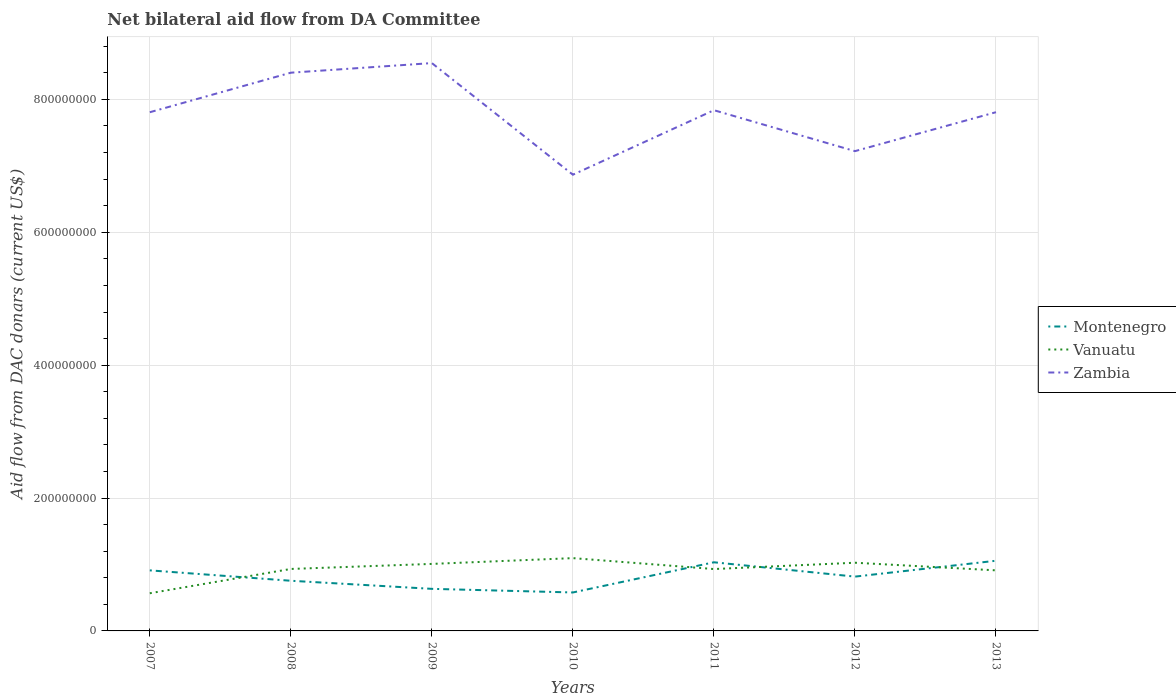Is the number of lines equal to the number of legend labels?
Make the answer very short. Yes. Across all years, what is the maximum aid flow in in Zambia?
Offer a terse response. 6.87e+08. In which year was the aid flow in in Vanuatu maximum?
Your response must be concise. 2007. What is the total aid flow in in Zambia in the graph?
Offer a terse response. 1.68e+08. What is the difference between the highest and the second highest aid flow in in Zambia?
Ensure brevity in your answer.  1.68e+08. What is the difference between the highest and the lowest aid flow in in Montenegro?
Make the answer very short. 3. How many legend labels are there?
Offer a very short reply. 3. How are the legend labels stacked?
Give a very brief answer. Vertical. What is the title of the graph?
Provide a short and direct response. Net bilateral aid flow from DA Committee. Does "Togo" appear as one of the legend labels in the graph?
Make the answer very short. No. What is the label or title of the Y-axis?
Offer a very short reply. Aid flow from DAC donars (current US$). What is the Aid flow from DAC donars (current US$) of Montenegro in 2007?
Offer a terse response. 9.11e+07. What is the Aid flow from DAC donars (current US$) in Vanuatu in 2007?
Provide a short and direct response. 5.67e+07. What is the Aid flow from DAC donars (current US$) in Zambia in 2007?
Ensure brevity in your answer.  7.81e+08. What is the Aid flow from DAC donars (current US$) of Montenegro in 2008?
Offer a very short reply. 7.55e+07. What is the Aid flow from DAC donars (current US$) of Vanuatu in 2008?
Offer a very short reply. 9.33e+07. What is the Aid flow from DAC donars (current US$) in Zambia in 2008?
Provide a short and direct response. 8.40e+08. What is the Aid flow from DAC donars (current US$) in Montenegro in 2009?
Offer a very short reply. 6.33e+07. What is the Aid flow from DAC donars (current US$) in Vanuatu in 2009?
Ensure brevity in your answer.  1.01e+08. What is the Aid flow from DAC donars (current US$) in Zambia in 2009?
Your answer should be very brief. 8.55e+08. What is the Aid flow from DAC donars (current US$) of Montenegro in 2010?
Provide a succinct answer. 5.79e+07. What is the Aid flow from DAC donars (current US$) in Vanuatu in 2010?
Give a very brief answer. 1.10e+08. What is the Aid flow from DAC donars (current US$) in Zambia in 2010?
Offer a terse response. 6.87e+08. What is the Aid flow from DAC donars (current US$) in Montenegro in 2011?
Keep it short and to the point. 1.03e+08. What is the Aid flow from DAC donars (current US$) in Vanuatu in 2011?
Your answer should be compact. 9.31e+07. What is the Aid flow from DAC donars (current US$) in Zambia in 2011?
Ensure brevity in your answer.  7.84e+08. What is the Aid flow from DAC donars (current US$) of Montenegro in 2012?
Ensure brevity in your answer.  8.17e+07. What is the Aid flow from DAC donars (current US$) in Vanuatu in 2012?
Offer a terse response. 1.03e+08. What is the Aid flow from DAC donars (current US$) of Zambia in 2012?
Your response must be concise. 7.22e+08. What is the Aid flow from DAC donars (current US$) in Montenegro in 2013?
Offer a terse response. 1.06e+08. What is the Aid flow from DAC donars (current US$) of Vanuatu in 2013?
Offer a terse response. 9.12e+07. What is the Aid flow from DAC donars (current US$) in Zambia in 2013?
Provide a short and direct response. 7.81e+08. Across all years, what is the maximum Aid flow from DAC donars (current US$) in Montenegro?
Give a very brief answer. 1.06e+08. Across all years, what is the maximum Aid flow from DAC donars (current US$) of Vanuatu?
Your answer should be compact. 1.10e+08. Across all years, what is the maximum Aid flow from DAC donars (current US$) of Zambia?
Offer a very short reply. 8.55e+08. Across all years, what is the minimum Aid flow from DAC donars (current US$) in Montenegro?
Offer a very short reply. 5.79e+07. Across all years, what is the minimum Aid flow from DAC donars (current US$) of Vanuatu?
Offer a terse response. 5.67e+07. Across all years, what is the minimum Aid flow from DAC donars (current US$) in Zambia?
Your response must be concise. 6.87e+08. What is the total Aid flow from DAC donars (current US$) of Montenegro in the graph?
Ensure brevity in your answer.  5.78e+08. What is the total Aid flow from DAC donars (current US$) of Vanuatu in the graph?
Keep it short and to the point. 6.47e+08. What is the total Aid flow from DAC donars (current US$) in Zambia in the graph?
Provide a short and direct response. 5.45e+09. What is the difference between the Aid flow from DAC donars (current US$) of Montenegro in 2007 and that in 2008?
Ensure brevity in your answer.  1.56e+07. What is the difference between the Aid flow from DAC donars (current US$) of Vanuatu in 2007 and that in 2008?
Your answer should be very brief. -3.66e+07. What is the difference between the Aid flow from DAC donars (current US$) of Zambia in 2007 and that in 2008?
Provide a succinct answer. -5.95e+07. What is the difference between the Aid flow from DAC donars (current US$) in Montenegro in 2007 and that in 2009?
Keep it short and to the point. 2.78e+07. What is the difference between the Aid flow from DAC donars (current US$) of Vanuatu in 2007 and that in 2009?
Give a very brief answer. -4.42e+07. What is the difference between the Aid flow from DAC donars (current US$) in Zambia in 2007 and that in 2009?
Give a very brief answer. -7.40e+07. What is the difference between the Aid flow from DAC donars (current US$) of Montenegro in 2007 and that in 2010?
Make the answer very short. 3.32e+07. What is the difference between the Aid flow from DAC donars (current US$) of Vanuatu in 2007 and that in 2010?
Offer a terse response. -5.29e+07. What is the difference between the Aid flow from DAC donars (current US$) of Zambia in 2007 and that in 2010?
Your response must be concise. 9.40e+07. What is the difference between the Aid flow from DAC donars (current US$) of Montenegro in 2007 and that in 2011?
Provide a short and direct response. -1.22e+07. What is the difference between the Aid flow from DAC donars (current US$) of Vanuatu in 2007 and that in 2011?
Your response must be concise. -3.64e+07. What is the difference between the Aid flow from DAC donars (current US$) in Zambia in 2007 and that in 2011?
Give a very brief answer. -3.05e+06. What is the difference between the Aid flow from DAC donars (current US$) in Montenegro in 2007 and that in 2012?
Give a very brief answer. 9.39e+06. What is the difference between the Aid flow from DAC donars (current US$) of Vanuatu in 2007 and that in 2012?
Your answer should be compact. -4.59e+07. What is the difference between the Aid flow from DAC donars (current US$) of Zambia in 2007 and that in 2012?
Ensure brevity in your answer.  5.86e+07. What is the difference between the Aid flow from DAC donars (current US$) of Montenegro in 2007 and that in 2013?
Your answer should be compact. -1.45e+07. What is the difference between the Aid flow from DAC donars (current US$) of Vanuatu in 2007 and that in 2013?
Your answer should be compact. -3.45e+07. What is the difference between the Aid flow from DAC donars (current US$) of Montenegro in 2008 and that in 2009?
Make the answer very short. 1.22e+07. What is the difference between the Aid flow from DAC donars (current US$) in Vanuatu in 2008 and that in 2009?
Your response must be concise. -7.60e+06. What is the difference between the Aid flow from DAC donars (current US$) in Zambia in 2008 and that in 2009?
Your answer should be very brief. -1.44e+07. What is the difference between the Aid flow from DAC donars (current US$) of Montenegro in 2008 and that in 2010?
Your response must be concise. 1.76e+07. What is the difference between the Aid flow from DAC donars (current US$) in Vanuatu in 2008 and that in 2010?
Make the answer very short. -1.63e+07. What is the difference between the Aid flow from DAC donars (current US$) in Zambia in 2008 and that in 2010?
Your answer should be very brief. 1.54e+08. What is the difference between the Aid flow from DAC donars (current US$) in Montenegro in 2008 and that in 2011?
Your answer should be compact. -2.78e+07. What is the difference between the Aid flow from DAC donars (current US$) of Zambia in 2008 and that in 2011?
Provide a succinct answer. 5.65e+07. What is the difference between the Aid flow from DAC donars (current US$) in Montenegro in 2008 and that in 2012?
Provide a succinct answer. -6.24e+06. What is the difference between the Aid flow from DAC donars (current US$) in Vanuatu in 2008 and that in 2012?
Offer a very short reply. -9.36e+06. What is the difference between the Aid flow from DAC donars (current US$) in Zambia in 2008 and that in 2012?
Offer a terse response. 1.18e+08. What is the difference between the Aid flow from DAC donars (current US$) of Montenegro in 2008 and that in 2013?
Keep it short and to the point. -3.01e+07. What is the difference between the Aid flow from DAC donars (current US$) in Vanuatu in 2008 and that in 2013?
Give a very brief answer. 2.11e+06. What is the difference between the Aid flow from DAC donars (current US$) of Zambia in 2008 and that in 2013?
Your answer should be very brief. 5.95e+07. What is the difference between the Aid flow from DAC donars (current US$) of Montenegro in 2009 and that in 2010?
Give a very brief answer. 5.44e+06. What is the difference between the Aid flow from DAC donars (current US$) in Vanuatu in 2009 and that in 2010?
Your answer should be very brief. -8.69e+06. What is the difference between the Aid flow from DAC donars (current US$) in Zambia in 2009 and that in 2010?
Provide a short and direct response. 1.68e+08. What is the difference between the Aid flow from DAC donars (current US$) of Montenegro in 2009 and that in 2011?
Your answer should be compact. -4.00e+07. What is the difference between the Aid flow from DAC donars (current US$) of Vanuatu in 2009 and that in 2011?
Ensure brevity in your answer.  7.74e+06. What is the difference between the Aid flow from DAC donars (current US$) in Zambia in 2009 and that in 2011?
Provide a succinct answer. 7.09e+07. What is the difference between the Aid flow from DAC donars (current US$) of Montenegro in 2009 and that in 2012?
Keep it short and to the point. -1.84e+07. What is the difference between the Aid flow from DAC donars (current US$) of Vanuatu in 2009 and that in 2012?
Keep it short and to the point. -1.76e+06. What is the difference between the Aid flow from DAC donars (current US$) of Zambia in 2009 and that in 2012?
Ensure brevity in your answer.  1.33e+08. What is the difference between the Aid flow from DAC donars (current US$) of Montenegro in 2009 and that in 2013?
Give a very brief answer. -4.23e+07. What is the difference between the Aid flow from DAC donars (current US$) of Vanuatu in 2009 and that in 2013?
Provide a succinct answer. 9.71e+06. What is the difference between the Aid flow from DAC donars (current US$) of Zambia in 2009 and that in 2013?
Your answer should be very brief. 7.39e+07. What is the difference between the Aid flow from DAC donars (current US$) in Montenegro in 2010 and that in 2011?
Keep it short and to the point. -4.54e+07. What is the difference between the Aid flow from DAC donars (current US$) of Vanuatu in 2010 and that in 2011?
Give a very brief answer. 1.64e+07. What is the difference between the Aid flow from DAC donars (current US$) of Zambia in 2010 and that in 2011?
Give a very brief answer. -9.71e+07. What is the difference between the Aid flow from DAC donars (current US$) in Montenegro in 2010 and that in 2012?
Make the answer very short. -2.39e+07. What is the difference between the Aid flow from DAC donars (current US$) of Vanuatu in 2010 and that in 2012?
Provide a succinct answer. 6.93e+06. What is the difference between the Aid flow from DAC donars (current US$) in Zambia in 2010 and that in 2012?
Give a very brief answer. -3.55e+07. What is the difference between the Aid flow from DAC donars (current US$) in Montenegro in 2010 and that in 2013?
Make the answer very short. -4.77e+07. What is the difference between the Aid flow from DAC donars (current US$) in Vanuatu in 2010 and that in 2013?
Your response must be concise. 1.84e+07. What is the difference between the Aid flow from DAC donars (current US$) in Zambia in 2010 and that in 2013?
Your answer should be compact. -9.41e+07. What is the difference between the Aid flow from DAC donars (current US$) in Montenegro in 2011 and that in 2012?
Give a very brief answer. 2.16e+07. What is the difference between the Aid flow from DAC donars (current US$) of Vanuatu in 2011 and that in 2012?
Provide a short and direct response. -9.50e+06. What is the difference between the Aid flow from DAC donars (current US$) in Zambia in 2011 and that in 2012?
Give a very brief answer. 6.16e+07. What is the difference between the Aid flow from DAC donars (current US$) of Montenegro in 2011 and that in 2013?
Your answer should be compact. -2.31e+06. What is the difference between the Aid flow from DAC donars (current US$) of Vanuatu in 2011 and that in 2013?
Give a very brief answer. 1.97e+06. What is the difference between the Aid flow from DAC donars (current US$) in Montenegro in 2012 and that in 2013?
Ensure brevity in your answer.  -2.39e+07. What is the difference between the Aid flow from DAC donars (current US$) in Vanuatu in 2012 and that in 2013?
Keep it short and to the point. 1.15e+07. What is the difference between the Aid flow from DAC donars (current US$) of Zambia in 2012 and that in 2013?
Make the answer very short. -5.86e+07. What is the difference between the Aid flow from DAC donars (current US$) in Montenegro in 2007 and the Aid flow from DAC donars (current US$) in Vanuatu in 2008?
Your response must be concise. -2.14e+06. What is the difference between the Aid flow from DAC donars (current US$) of Montenegro in 2007 and the Aid flow from DAC donars (current US$) of Zambia in 2008?
Offer a terse response. -7.49e+08. What is the difference between the Aid flow from DAC donars (current US$) in Vanuatu in 2007 and the Aid flow from DAC donars (current US$) in Zambia in 2008?
Provide a succinct answer. -7.84e+08. What is the difference between the Aid flow from DAC donars (current US$) of Montenegro in 2007 and the Aid flow from DAC donars (current US$) of Vanuatu in 2009?
Ensure brevity in your answer.  -9.74e+06. What is the difference between the Aid flow from DAC donars (current US$) of Montenegro in 2007 and the Aid flow from DAC donars (current US$) of Zambia in 2009?
Provide a short and direct response. -7.64e+08. What is the difference between the Aid flow from DAC donars (current US$) in Vanuatu in 2007 and the Aid flow from DAC donars (current US$) in Zambia in 2009?
Provide a succinct answer. -7.98e+08. What is the difference between the Aid flow from DAC donars (current US$) in Montenegro in 2007 and the Aid flow from DAC donars (current US$) in Vanuatu in 2010?
Your answer should be compact. -1.84e+07. What is the difference between the Aid flow from DAC donars (current US$) of Montenegro in 2007 and the Aid flow from DAC donars (current US$) of Zambia in 2010?
Ensure brevity in your answer.  -5.96e+08. What is the difference between the Aid flow from DAC donars (current US$) in Vanuatu in 2007 and the Aid flow from DAC donars (current US$) in Zambia in 2010?
Provide a short and direct response. -6.30e+08. What is the difference between the Aid flow from DAC donars (current US$) of Montenegro in 2007 and the Aid flow from DAC donars (current US$) of Zambia in 2011?
Offer a terse response. -6.93e+08. What is the difference between the Aid flow from DAC donars (current US$) of Vanuatu in 2007 and the Aid flow from DAC donars (current US$) of Zambia in 2011?
Make the answer very short. -7.27e+08. What is the difference between the Aid flow from DAC donars (current US$) in Montenegro in 2007 and the Aid flow from DAC donars (current US$) in Vanuatu in 2012?
Your response must be concise. -1.15e+07. What is the difference between the Aid flow from DAC donars (current US$) in Montenegro in 2007 and the Aid flow from DAC donars (current US$) in Zambia in 2012?
Your answer should be compact. -6.31e+08. What is the difference between the Aid flow from DAC donars (current US$) in Vanuatu in 2007 and the Aid flow from DAC donars (current US$) in Zambia in 2012?
Provide a succinct answer. -6.65e+08. What is the difference between the Aid flow from DAC donars (current US$) in Montenegro in 2007 and the Aid flow from DAC donars (current US$) in Vanuatu in 2013?
Give a very brief answer. -3.00e+04. What is the difference between the Aid flow from DAC donars (current US$) of Montenegro in 2007 and the Aid flow from DAC donars (current US$) of Zambia in 2013?
Provide a short and direct response. -6.90e+08. What is the difference between the Aid flow from DAC donars (current US$) in Vanuatu in 2007 and the Aid flow from DAC donars (current US$) in Zambia in 2013?
Give a very brief answer. -7.24e+08. What is the difference between the Aid flow from DAC donars (current US$) of Montenegro in 2008 and the Aid flow from DAC donars (current US$) of Vanuatu in 2009?
Make the answer very short. -2.54e+07. What is the difference between the Aid flow from DAC donars (current US$) of Montenegro in 2008 and the Aid flow from DAC donars (current US$) of Zambia in 2009?
Your response must be concise. -7.79e+08. What is the difference between the Aid flow from DAC donars (current US$) in Vanuatu in 2008 and the Aid flow from DAC donars (current US$) in Zambia in 2009?
Provide a short and direct response. -7.61e+08. What is the difference between the Aid flow from DAC donars (current US$) in Montenegro in 2008 and the Aid flow from DAC donars (current US$) in Vanuatu in 2010?
Your answer should be very brief. -3.41e+07. What is the difference between the Aid flow from DAC donars (current US$) in Montenegro in 2008 and the Aid flow from DAC donars (current US$) in Zambia in 2010?
Offer a very short reply. -6.11e+08. What is the difference between the Aid flow from DAC donars (current US$) of Vanuatu in 2008 and the Aid flow from DAC donars (current US$) of Zambia in 2010?
Keep it short and to the point. -5.93e+08. What is the difference between the Aid flow from DAC donars (current US$) in Montenegro in 2008 and the Aid flow from DAC donars (current US$) in Vanuatu in 2011?
Make the answer very short. -1.76e+07. What is the difference between the Aid flow from DAC donars (current US$) in Montenegro in 2008 and the Aid flow from DAC donars (current US$) in Zambia in 2011?
Keep it short and to the point. -7.08e+08. What is the difference between the Aid flow from DAC donars (current US$) of Vanuatu in 2008 and the Aid flow from DAC donars (current US$) of Zambia in 2011?
Your response must be concise. -6.90e+08. What is the difference between the Aid flow from DAC donars (current US$) of Montenegro in 2008 and the Aid flow from DAC donars (current US$) of Vanuatu in 2012?
Offer a terse response. -2.71e+07. What is the difference between the Aid flow from DAC donars (current US$) in Montenegro in 2008 and the Aid flow from DAC donars (current US$) in Zambia in 2012?
Provide a short and direct response. -6.47e+08. What is the difference between the Aid flow from DAC donars (current US$) in Vanuatu in 2008 and the Aid flow from DAC donars (current US$) in Zambia in 2012?
Your response must be concise. -6.29e+08. What is the difference between the Aid flow from DAC donars (current US$) of Montenegro in 2008 and the Aid flow from DAC donars (current US$) of Vanuatu in 2013?
Provide a short and direct response. -1.57e+07. What is the difference between the Aid flow from DAC donars (current US$) of Montenegro in 2008 and the Aid flow from DAC donars (current US$) of Zambia in 2013?
Give a very brief answer. -7.05e+08. What is the difference between the Aid flow from DAC donars (current US$) in Vanuatu in 2008 and the Aid flow from DAC donars (current US$) in Zambia in 2013?
Keep it short and to the point. -6.87e+08. What is the difference between the Aid flow from DAC donars (current US$) of Montenegro in 2009 and the Aid flow from DAC donars (current US$) of Vanuatu in 2010?
Offer a very short reply. -4.62e+07. What is the difference between the Aid flow from DAC donars (current US$) in Montenegro in 2009 and the Aid flow from DAC donars (current US$) in Zambia in 2010?
Provide a short and direct response. -6.23e+08. What is the difference between the Aid flow from DAC donars (current US$) of Vanuatu in 2009 and the Aid flow from DAC donars (current US$) of Zambia in 2010?
Provide a short and direct response. -5.86e+08. What is the difference between the Aid flow from DAC donars (current US$) in Montenegro in 2009 and the Aid flow from DAC donars (current US$) in Vanuatu in 2011?
Make the answer very short. -2.98e+07. What is the difference between the Aid flow from DAC donars (current US$) of Montenegro in 2009 and the Aid flow from DAC donars (current US$) of Zambia in 2011?
Make the answer very short. -7.20e+08. What is the difference between the Aid flow from DAC donars (current US$) in Vanuatu in 2009 and the Aid flow from DAC donars (current US$) in Zambia in 2011?
Make the answer very short. -6.83e+08. What is the difference between the Aid flow from DAC donars (current US$) of Montenegro in 2009 and the Aid flow from DAC donars (current US$) of Vanuatu in 2012?
Your answer should be very brief. -3.93e+07. What is the difference between the Aid flow from DAC donars (current US$) of Montenegro in 2009 and the Aid flow from DAC donars (current US$) of Zambia in 2012?
Your answer should be very brief. -6.59e+08. What is the difference between the Aid flow from DAC donars (current US$) of Vanuatu in 2009 and the Aid flow from DAC donars (current US$) of Zambia in 2012?
Keep it short and to the point. -6.21e+08. What is the difference between the Aid flow from DAC donars (current US$) of Montenegro in 2009 and the Aid flow from DAC donars (current US$) of Vanuatu in 2013?
Your response must be concise. -2.78e+07. What is the difference between the Aid flow from DAC donars (current US$) of Montenegro in 2009 and the Aid flow from DAC donars (current US$) of Zambia in 2013?
Make the answer very short. -7.17e+08. What is the difference between the Aid flow from DAC donars (current US$) of Vanuatu in 2009 and the Aid flow from DAC donars (current US$) of Zambia in 2013?
Give a very brief answer. -6.80e+08. What is the difference between the Aid flow from DAC donars (current US$) in Montenegro in 2010 and the Aid flow from DAC donars (current US$) in Vanuatu in 2011?
Provide a succinct answer. -3.52e+07. What is the difference between the Aid flow from DAC donars (current US$) in Montenegro in 2010 and the Aid flow from DAC donars (current US$) in Zambia in 2011?
Give a very brief answer. -7.26e+08. What is the difference between the Aid flow from DAC donars (current US$) of Vanuatu in 2010 and the Aid flow from DAC donars (current US$) of Zambia in 2011?
Make the answer very short. -6.74e+08. What is the difference between the Aid flow from DAC donars (current US$) in Montenegro in 2010 and the Aid flow from DAC donars (current US$) in Vanuatu in 2012?
Your answer should be very brief. -4.48e+07. What is the difference between the Aid flow from DAC donars (current US$) of Montenegro in 2010 and the Aid flow from DAC donars (current US$) of Zambia in 2012?
Offer a very short reply. -6.64e+08. What is the difference between the Aid flow from DAC donars (current US$) of Vanuatu in 2010 and the Aid flow from DAC donars (current US$) of Zambia in 2012?
Your answer should be very brief. -6.13e+08. What is the difference between the Aid flow from DAC donars (current US$) in Montenegro in 2010 and the Aid flow from DAC donars (current US$) in Vanuatu in 2013?
Keep it short and to the point. -3.33e+07. What is the difference between the Aid flow from DAC donars (current US$) in Montenegro in 2010 and the Aid flow from DAC donars (current US$) in Zambia in 2013?
Provide a short and direct response. -7.23e+08. What is the difference between the Aid flow from DAC donars (current US$) in Vanuatu in 2010 and the Aid flow from DAC donars (current US$) in Zambia in 2013?
Provide a short and direct response. -6.71e+08. What is the difference between the Aid flow from DAC donars (current US$) of Montenegro in 2011 and the Aid flow from DAC donars (current US$) of Vanuatu in 2012?
Ensure brevity in your answer.  6.80e+05. What is the difference between the Aid flow from DAC donars (current US$) of Montenegro in 2011 and the Aid flow from DAC donars (current US$) of Zambia in 2012?
Your response must be concise. -6.19e+08. What is the difference between the Aid flow from DAC donars (current US$) in Vanuatu in 2011 and the Aid flow from DAC donars (current US$) in Zambia in 2012?
Provide a succinct answer. -6.29e+08. What is the difference between the Aid flow from DAC donars (current US$) in Montenegro in 2011 and the Aid flow from DAC donars (current US$) in Vanuatu in 2013?
Offer a very short reply. 1.22e+07. What is the difference between the Aid flow from DAC donars (current US$) of Montenegro in 2011 and the Aid flow from DAC donars (current US$) of Zambia in 2013?
Give a very brief answer. -6.77e+08. What is the difference between the Aid flow from DAC donars (current US$) in Vanuatu in 2011 and the Aid flow from DAC donars (current US$) in Zambia in 2013?
Provide a succinct answer. -6.88e+08. What is the difference between the Aid flow from DAC donars (current US$) in Montenegro in 2012 and the Aid flow from DAC donars (current US$) in Vanuatu in 2013?
Your answer should be very brief. -9.42e+06. What is the difference between the Aid flow from DAC donars (current US$) in Montenegro in 2012 and the Aid flow from DAC donars (current US$) in Zambia in 2013?
Your answer should be compact. -6.99e+08. What is the difference between the Aid flow from DAC donars (current US$) in Vanuatu in 2012 and the Aid flow from DAC donars (current US$) in Zambia in 2013?
Your answer should be very brief. -6.78e+08. What is the average Aid flow from DAC donars (current US$) of Montenegro per year?
Keep it short and to the point. 8.26e+07. What is the average Aid flow from DAC donars (current US$) of Vanuatu per year?
Your response must be concise. 9.25e+07. What is the average Aid flow from DAC donars (current US$) in Zambia per year?
Offer a very short reply. 7.78e+08. In the year 2007, what is the difference between the Aid flow from DAC donars (current US$) in Montenegro and Aid flow from DAC donars (current US$) in Vanuatu?
Ensure brevity in your answer.  3.44e+07. In the year 2007, what is the difference between the Aid flow from DAC donars (current US$) of Montenegro and Aid flow from DAC donars (current US$) of Zambia?
Provide a succinct answer. -6.90e+08. In the year 2007, what is the difference between the Aid flow from DAC donars (current US$) of Vanuatu and Aid flow from DAC donars (current US$) of Zambia?
Offer a very short reply. -7.24e+08. In the year 2008, what is the difference between the Aid flow from DAC donars (current US$) of Montenegro and Aid flow from DAC donars (current US$) of Vanuatu?
Your answer should be compact. -1.78e+07. In the year 2008, what is the difference between the Aid flow from DAC donars (current US$) in Montenegro and Aid flow from DAC donars (current US$) in Zambia?
Give a very brief answer. -7.65e+08. In the year 2008, what is the difference between the Aid flow from DAC donars (current US$) in Vanuatu and Aid flow from DAC donars (current US$) in Zambia?
Offer a very short reply. -7.47e+08. In the year 2009, what is the difference between the Aid flow from DAC donars (current US$) in Montenegro and Aid flow from DAC donars (current US$) in Vanuatu?
Offer a very short reply. -3.76e+07. In the year 2009, what is the difference between the Aid flow from DAC donars (current US$) in Montenegro and Aid flow from DAC donars (current US$) in Zambia?
Provide a short and direct response. -7.91e+08. In the year 2009, what is the difference between the Aid flow from DAC donars (current US$) of Vanuatu and Aid flow from DAC donars (current US$) of Zambia?
Keep it short and to the point. -7.54e+08. In the year 2010, what is the difference between the Aid flow from DAC donars (current US$) of Montenegro and Aid flow from DAC donars (current US$) of Vanuatu?
Ensure brevity in your answer.  -5.17e+07. In the year 2010, what is the difference between the Aid flow from DAC donars (current US$) of Montenegro and Aid flow from DAC donars (current US$) of Zambia?
Provide a succinct answer. -6.29e+08. In the year 2010, what is the difference between the Aid flow from DAC donars (current US$) in Vanuatu and Aid flow from DAC donars (current US$) in Zambia?
Give a very brief answer. -5.77e+08. In the year 2011, what is the difference between the Aid flow from DAC donars (current US$) of Montenegro and Aid flow from DAC donars (current US$) of Vanuatu?
Your response must be concise. 1.02e+07. In the year 2011, what is the difference between the Aid flow from DAC donars (current US$) in Montenegro and Aid flow from DAC donars (current US$) in Zambia?
Keep it short and to the point. -6.80e+08. In the year 2011, what is the difference between the Aid flow from DAC donars (current US$) of Vanuatu and Aid flow from DAC donars (current US$) of Zambia?
Make the answer very short. -6.91e+08. In the year 2012, what is the difference between the Aid flow from DAC donars (current US$) in Montenegro and Aid flow from DAC donars (current US$) in Vanuatu?
Ensure brevity in your answer.  -2.09e+07. In the year 2012, what is the difference between the Aid flow from DAC donars (current US$) of Montenegro and Aid flow from DAC donars (current US$) of Zambia?
Give a very brief answer. -6.40e+08. In the year 2012, what is the difference between the Aid flow from DAC donars (current US$) of Vanuatu and Aid flow from DAC donars (current US$) of Zambia?
Make the answer very short. -6.19e+08. In the year 2013, what is the difference between the Aid flow from DAC donars (current US$) in Montenegro and Aid flow from DAC donars (current US$) in Vanuatu?
Your answer should be compact. 1.45e+07. In the year 2013, what is the difference between the Aid flow from DAC donars (current US$) in Montenegro and Aid flow from DAC donars (current US$) in Zambia?
Make the answer very short. -6.75e+08. In the year 2013, what is the difference between the Aid flow from DAC donars (current US$) of Vanuatu and Aid flow from DAC donars (current US$) of Zambia?
Ensure brevity in your answer.  -6.90e+08. What is the ratio of the Aid flow from DAC donars (current US$) in Montenegro in 2007 to that in 2008?
Make the answer very short. 1.21. What is the ratio of the Aid flow from DAC donars (current US$) of Vanuatu in 2007 to that in 2008?
Offer a very short reply. 0.61. What is the ratio of the Aid flow from DAC donars (current US$) of Zambia in 2007 to that in 2008?
Keep it short and to the point. 0.93. What is the ratio of the Aid flow from DAC donars (current US$) in Montenegro in 2007 to that in 2009?
Give a very brief answer. 1.44. What is the ratio of the Aid flow from DAC donars (current US$) in Vanuatu in 2007 to that in 2009?
Give a very brief answer. 0.56. What is the ratio of the Aid flow from DAC donars (current US$) in Zambia in 2007 to that in 2009?
Provide a succinct answer. 0.91. What is the ratio of the Aid flow from DAC donars (current US$) in Montenegro in 2007 to that in 2010?
Keep it short and to the point. 1.57. What is the ratio of the Aid flow from DAC donars (current US$) in Vanuatu in 2007 to that in 2010?
Give a very brief answer. 0.52. What is the ratio of the Aid flow from DAC donars (current US$) of Zambia in 2007 to that in 2010?
Make the answer very short. 1.14. What is the ratio of the Aid flow from DAC donars (current US$) in Montenegro in 2007 to that in 2011?
Offer a terse response. 0.88. What is the ratio of the Aid flow from DAC donars (current US$) of Vanuatu in 2007 to that in 2011?
Your answer should be very brief. 0.61. What is the ratio of the Aid flow from DAC donars (current US$) in Montenegro in 2007 to that in 2012?
Your answer should be very brief. 1.11. What is the ratio of the Aid flow from DAC donars (current US$) in Vanuatu in 2007 to that in 2012?
Provide a short and direct response. 0.55. What is the ratio of the Aid flow from DAC donars (current US$) in Zambia in 2007 to that in 2012?
Offer a terse response. 1.08. What is the ratio of the Aid flow from DAC donars (current US$) in Montenegro in 2007 to that in 2013?
Give a very brief answer. 0.86. What is the ratio of the Aid flow from DAC donars (current US$) in Vanuatu in 2007 to that in 2013?
Provide a short and direct response. 0.62. What is the ratio of the Aid flow from DAC donars (current US$) in Montenegro in 2008 to that in 2009?
Keep it short and to the point. 1.19. What is the ratio of the Aid flow from DAC donars (current US$) of Vanuatu in 2008 to that in 2009?
Your answer should be very brief. 0.92. What is the ratio of the Aid flow from DAC donars (current US$) in Zambia in 2008 to that in 2009?
Offer a very short reply. 0.98. What is the ratio of the Aid flow from DAC donars (current US$) of Montenegro in 2008 to that in 2010?
Offer a terse response. 1.3. What is the ratio of the Aid flow from DAC donars (current US$) of Vanuatu in 2008 to that in 2010?
Offer a terse response. 0.85. What is the ratio of the Aid flow from DAC donars (current US$) of Zambia in 2008 to that in 2010?
Ensure brevity in your answer.  1.22. What is the ratio of the Aid flow from DAC donars (current US$) in Montenegro in 2008 to that in 2011?
Provide a short and direct response. 0.73. What is the ratio of the Aid flow from DAC donars (current US$) in Vanuatu in 2008 to that in 2011?
Your answer should be very brief. 1. What is the ratio of the Aid flow from DAC donars (current US$) of Zambia in 2008 to that in 2011?
Provide a short and direct response. 1.07. What is the ratio of the Aid flow from DAC donars (current US$) in Montenegro in 2008 to that in 2012?
Provide a short and direct response. 0.92. What is the ratio of the Aid flow from DAC donars (current US$) in Vanuatu in 2008 to that in 2012?
Keep it short and to the point. 0.91. What is the ratio of the Aid flow from DAC donars (current US$) of Zambia in 2008 to that in 2012?
Ensure brevity in your answer.  1.16. What is the ratio of the Aid flow from DAC donars (current US$) of Montenegro in 2008 to that in 2013?
Your answer should be compact. 0.71. What is the ratio of the Aid flow from DAC donars (current US$) of Vanuatu in 2008 to that in 2013?
Offer a terse response. 1.02. What is the ratio of the Aid flow from DAC donars (current US$) in Zambia in 2008 to that in 2013?
Your answer should be very brief. 1.08. What is the ratio of the Aid flow from DAC donars (current US$) of Montenegro in 2009 to that in 2010?
Your answer should be compact. 1.09. What is the ratio of the Aid flow from DAC donars (current US$) of Vanuatu in 2009 to that in 2010?
Keep it short and to the point. 0.92. What is the ratio of the Aid flow from DAC donars (current US$) of Zambia in 2009 to that in 2010?
Ensure brevity in your answer.  1.24. What is the ratio of the Aid flow from DAC donars (current US$) in Montenegro in 2009 to that in 2011?
Your response must be concise. 0.61. What is the ratio of the Aid flow from DAC donars (current US$) in Vanuatu in 2009 to that in 2011?
Give a very brief answer. 1.08. What is the ratio of the Aid flow from DAC donars (current US$) in Zambia in 2009 to that in 2011?
Provide a succinct answer. 1.09. What is the ratio of the Aid flow from DAC donars (current US$) in Montenegro in 2009 to that in 2012?
Keep it short and to the point. 0.77. What is the ratio of the Aid flow from DAC donars (current US$) of Vanuatu in 2009 to that in 2012?
Your answer should be compact. 0.98. What is the ratio of the Aid flow from DAC donars (current US$) in Zambia in 2009 to that in 2012?
Offer a terse response. 1.18. What is the ratio of the Aid flow from DAC donars (current US$) of Montenegro in 2009 to that in 2013?
Give a very brief answer. 0.6. What is the ratio of the Aid flow from DAC donars (current US$) of Vanuatu in 2009 to that in 2013?
Provide a short and direct response. 1.11. What is the ratio of the Aid flow from DAC donars (current US$) in Zambia in 2009 to that in 2013?
Your answer should be compact. 1.09. What is the ratio of the Aid flow from DAC donars (current US$) in Montenegro in 2010 to that in 2011?
Provide a succinct answer. 0.56. What is the ratio of the Aid flow from DAC donars (current US$) in Vanuatu in 2010 to that in 2011?
Your response must be concise. 1.18. What is the ratio of the Aid flow from DAC donars (current US$) in Zambia in 2010 to that in 2011?
Your response must be concise. 0.88. What is the ratio of the Aid flow from DAC donars (current US$) of Montenegro in 2010 to that in 2012?
Give a very brief answer. 0.71. What is the ratio of the Aid flow from DAC donars (current US$) of Vanuatu in 2010 to that in 2012?
Offer a terse response. 1.07. What is the ratio of the Aid flow from DAC donars (current US$) of Zambia in 2010 to that in 2012?
Ensure brevity in your answer.  0.95. What is the ratio of the Aid flow from DAC donars (current US$) of Montenegro in 2010 to that in 2013?
Your answer should be compact. 0.55. What is the ratio of the Aid flow from DAC donars (current US$) in Vanuatu in 2010 to that in 2013?
Keep it short and to the point. 1.2. What is the ratio of the Aid flow from DAC donars (current US$) in Zambia in 2010 to that in 2013?
Your response must be concise. 0.88. What is the ratio of the Aid flow from DAC donars (current US$) of Montenegro in 2011 to that in 2012?
Give a very brief answer. 1.26. What is the ratio of the Aid flow from DAC donars (current US$) in Vanuatu in 2011 to that in 2012?
Ensure brevity in your answer.  0.91. What is the ratio of the Aid flow from DAC donars (current US$) in Zambia in 2011 to that in 2012?
Your answer should be compact. 1.09. What is the ratio of the Aid flow from DAC donars (current US$) in Montenegro in 2011 to that in 2013?
Your answer should be very brief. 0.98. What is the ratio of the Aid flow from DAC donars (current US$) in Vanuatu in 2011 to that in 2013?
Provide a short and direct response. 1.02. What is the ratio of the Aid flow from DAC donars (current US$) in Montenegro in 2012 to that in 2013?
Your response must be concise. 0.77. What is the ratio of the Aid flow from DAC donars (current US$) of Vanuatu in 2012 to that in 2013?
Give a very brief answer. 1.13. What is the ratio of the Aid flow from DAC donars (current US$) of Zambia in 2012 to that in 2013?
Offer a terse response. 0.92. What is the difference between the highest and the second highest Aid flow from DAC donars (current US$) in Montenegro?
Ensure brevity in your answer.  2.31e+06. What is the difference between the highest and the second highest Aid flow from DAC donars (current US$) of Vanuatu?
Provide a succinct answer. 6.93e+06. What is the difference between the highest and the second highest Aid flow from DAC donars (current US$) in Zambia?
Offer a very short reply. 1.44e+07. What is the difference between the highest and the lowest Aid flow from DAC donars (current US$) of Montenegro?
Your answer should be compact. 4.77e+07. What is the difference between the highest and the lowest Aid flow from DAC donars (current US$) in Vanuatu?
Make the answer very short. 5.29e+07. What is the difference between the highest and the lowest Aid flow from DAC donars (current US$) in Zambia?
Provide a short and direct response. 1.68e+08. 